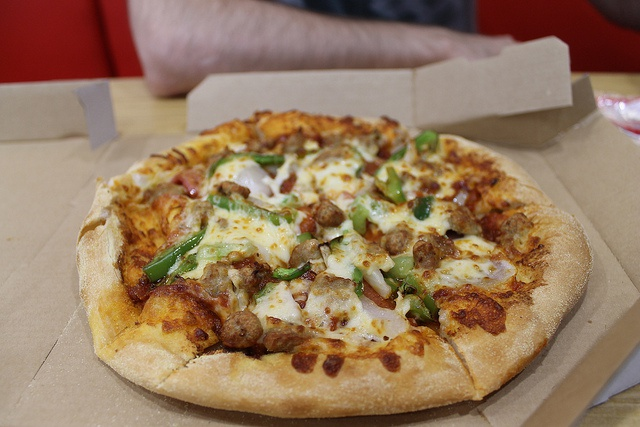Describe the objects in this image and their specific colors. I can see dining table in darkgray, maroon, tan, olive, and gray tones, pizza in maroon, tan, and olive tones, pizza in maroon, tan, and olive tones, people in gray, maroon, and darkgray tones, and pizza in maroon, olive, and tan tones in this image. 